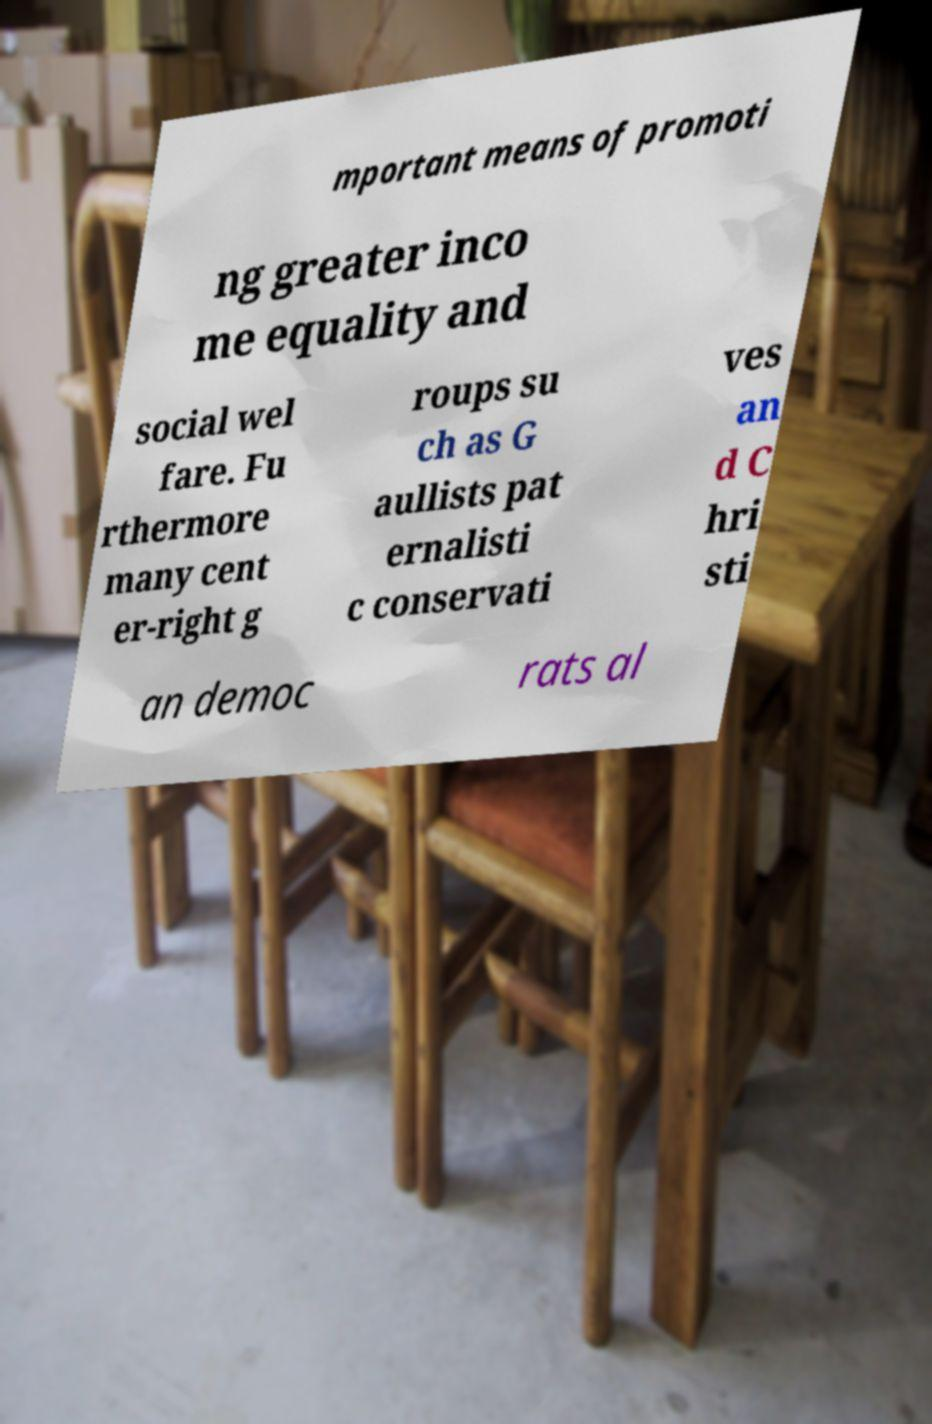Please identify and transcribe the text found in this image. mportant means of promoti ng greater inco me equality and social wel fare. Fu rthermore many cent er-right g roups su ch as G aullists pat ernalisti c conservati ves an d C hri sti an democ rats al 